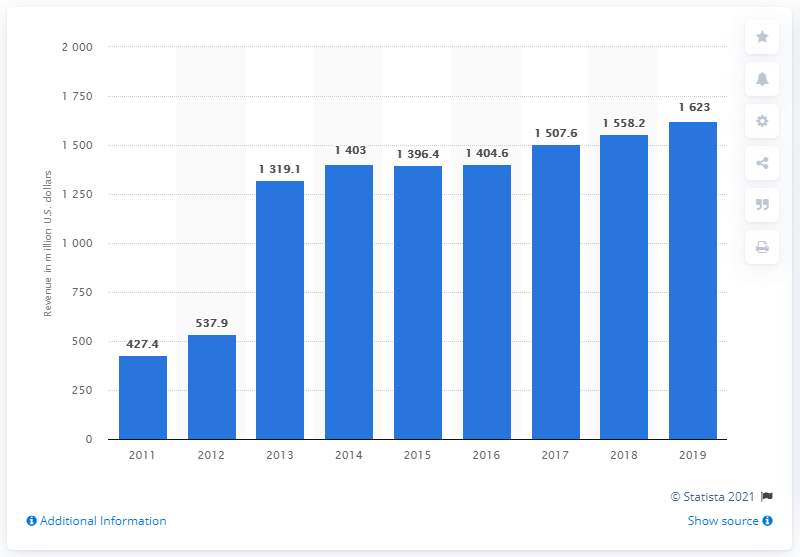Mention a couple of crucial points in this snapshot. In 2011, Advanced Disposal Services, Inc. reported its first service revenue. 